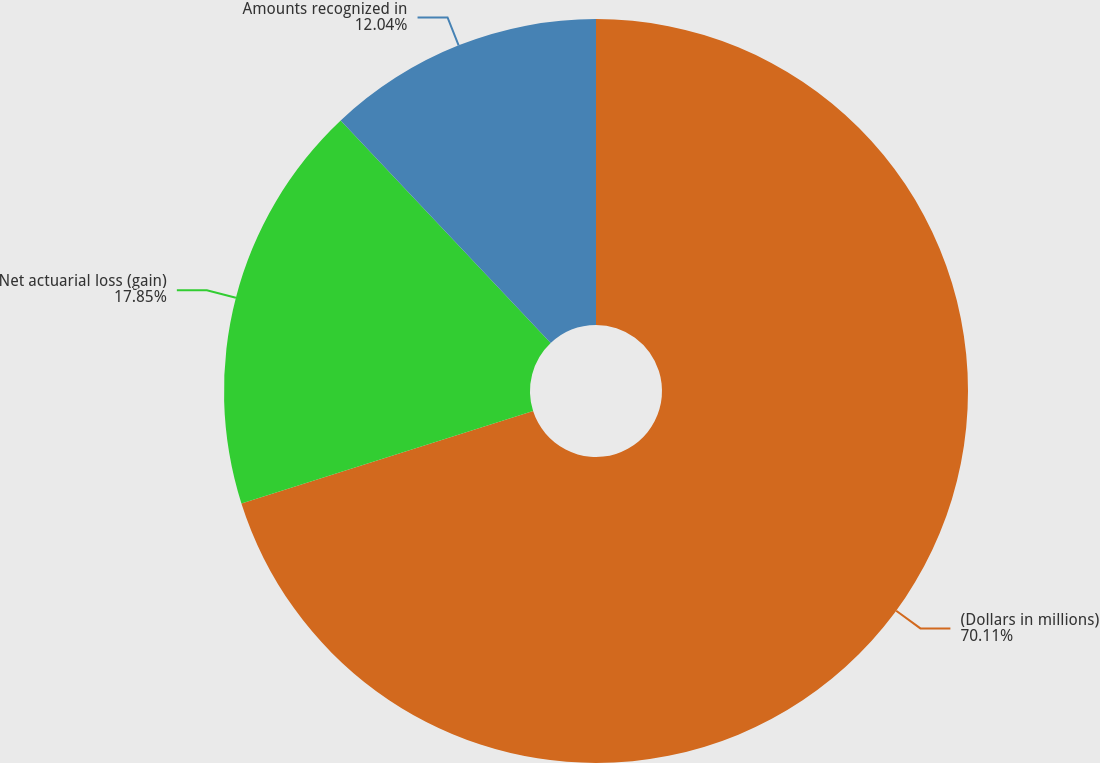Convert chart. <chart><loc_0><loc_0><loc_500><loc_500><pie_chart><fcel>(Dollars in millions)<fcel>Net actuarial loss (gain)<fcel>Amounts recognized in<nl><fcel>70.11%<fcel>17.85%<fcel>12.04%<nl></chart> 